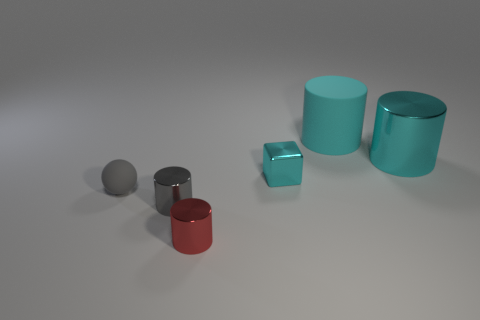Can you describe the textures and shapes present in this collection of objects? Certainly! The objects exhibit three primary shapes: cubes and cylinders, along with a sphere. Their surfaces range from matte to shiny, indicating different textures. The matte sphere provides a contrast to the reflective qualities of the metal cylinders and cube. 